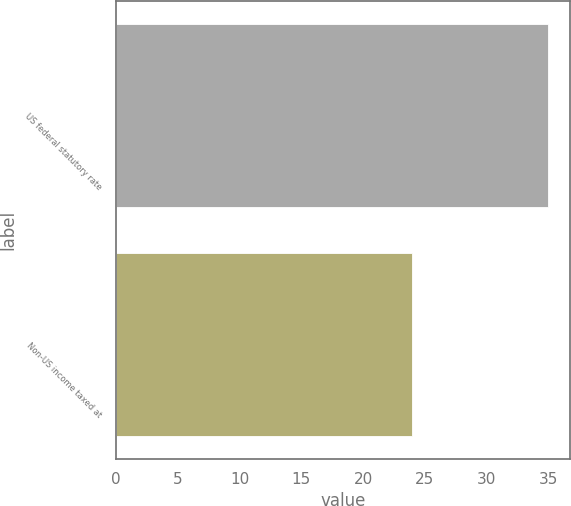<chart> <loc_0><loc_0><loc_500><loc_500><bar_chart><fcel>US federal statutory rate<fcel>Non-US income taxed at<nl><fcel>35<fcel>24<nl></chart> 